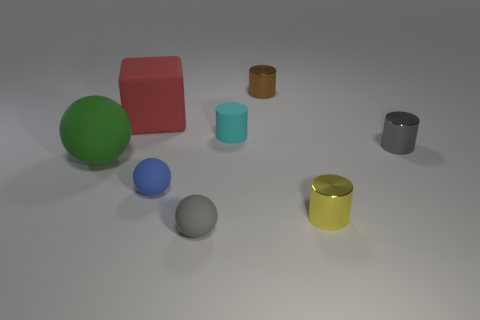How many brown cubes have the same size as the yellow thing?
Your response must be concise. 0. Are there fewer yellow things behind the matte cylinder than big brown balls?
Provide a short and direct response. No. How many green matte things are behind the gray sphere?
Offer a terse response. 1. There is a metallic thing that is in front of the small gray object right of the cylinder to the left of the brown shiny object; what size is it?
Provide a short and direct response. Small. Does the large red matte object have the same shape as the big rubber object on the left side of the big block?
Provide a short and direct response. No. What size is the gray sphere that is made of the same material as the large red block?
Your answer should be very brief. Small. Is there anything else of the same color as the rubber cylinder?
Ensure brevity in your answer.  No. What is the gray object left of the gray thing that is behind the tiny gray object on the left side of the small cyan cylinder made of?
Ensure brevity in your answer.  Rubber. What number of rubber things are either blocks or large things?
Provide a succinct answer. 2. Does the large ball have the same color as the large block?
Your response must be concise. No. 